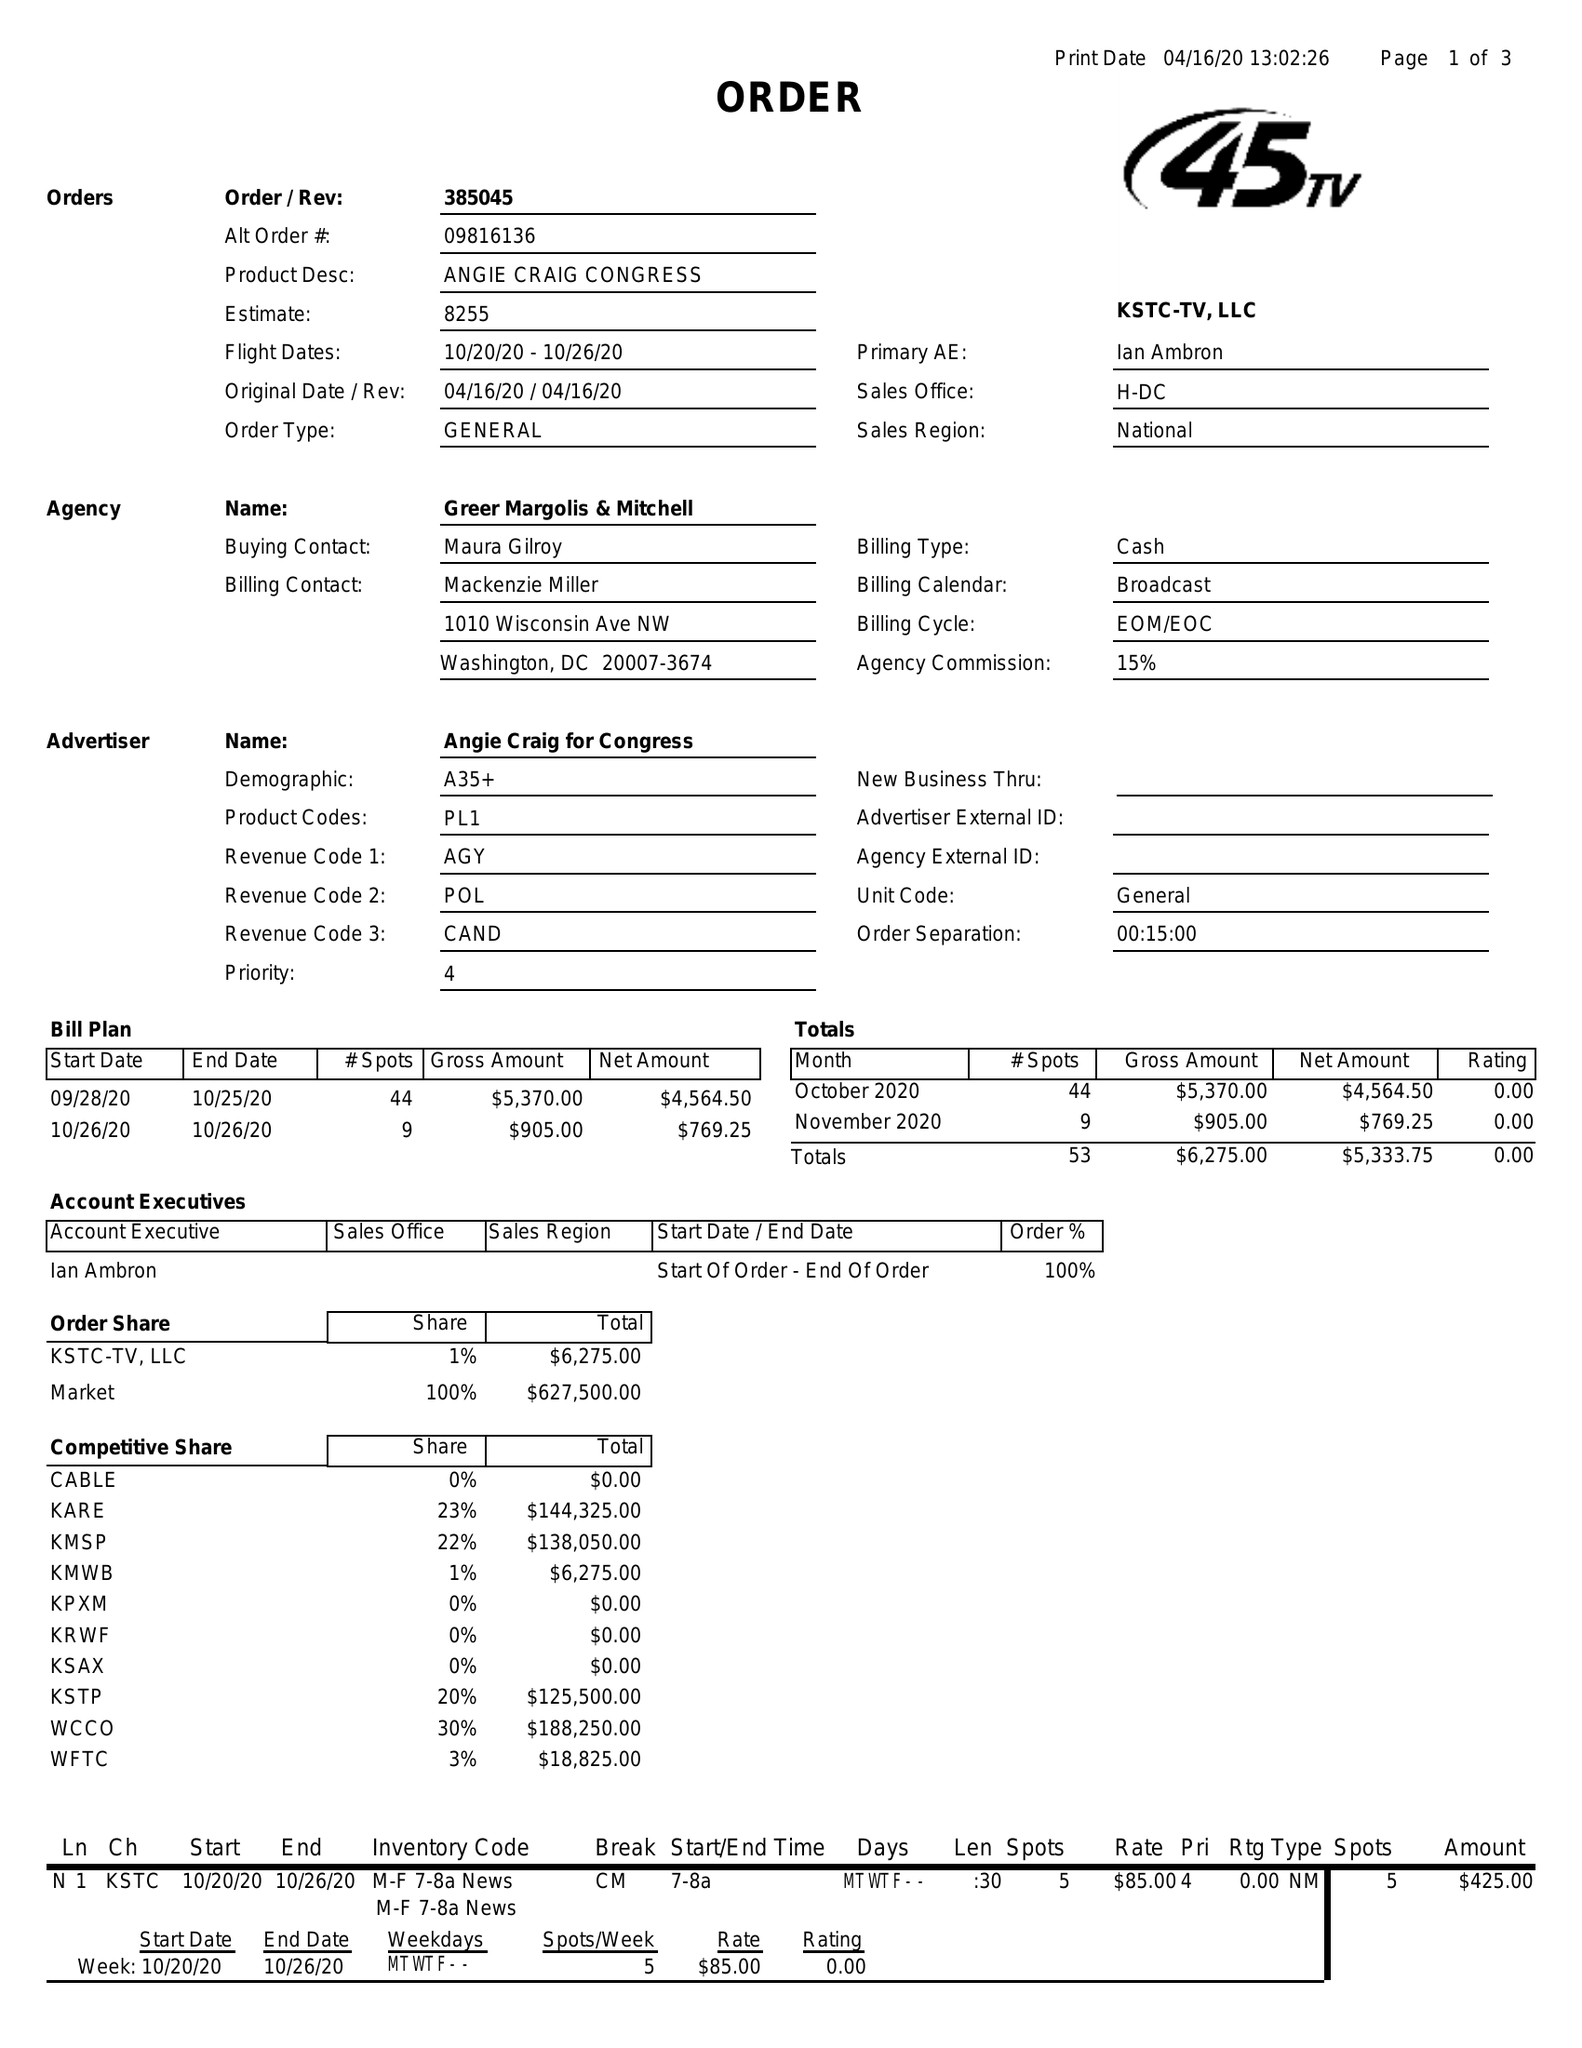What is the value for the flight_to?
Answer the question using a single word or phrase. 10/26/20 